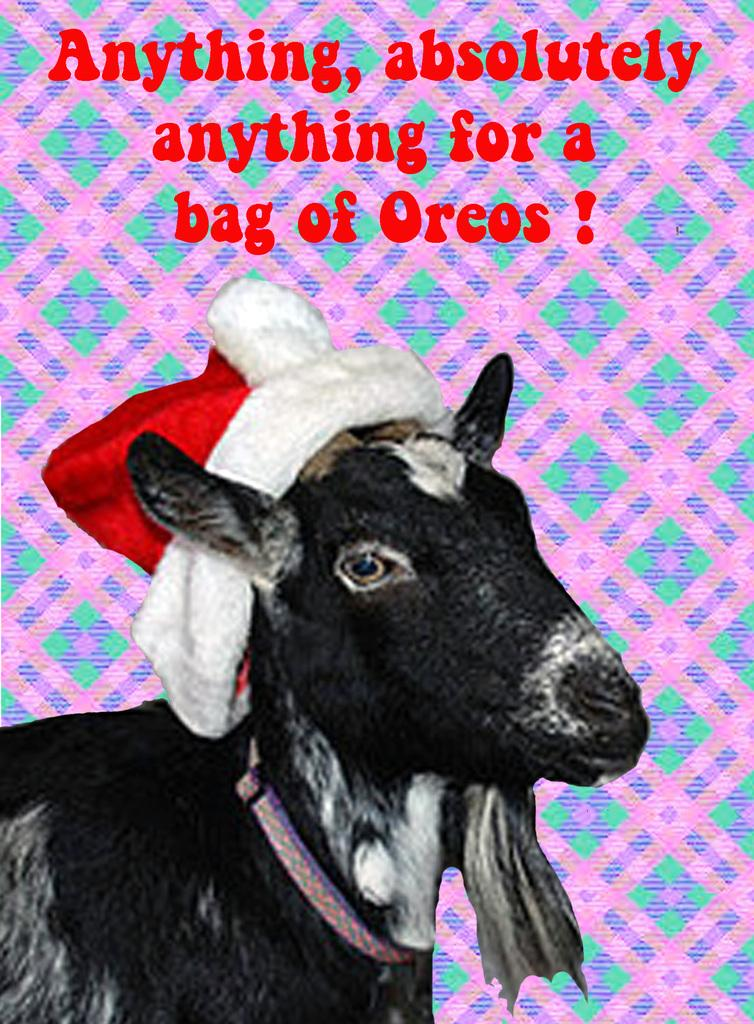What animal is present in the picture? There is a goat in the picture. What is the goat wearing? The goat is wearing a Christmas cap. Is there any text present in the image? Yes, there is text at the top of the picture. What scientific discovery is mentioned in the text at the top of the image? There is no scientific discovery mentioned in the text at the top of the image, as the provided facts do not mention any scientific content. 